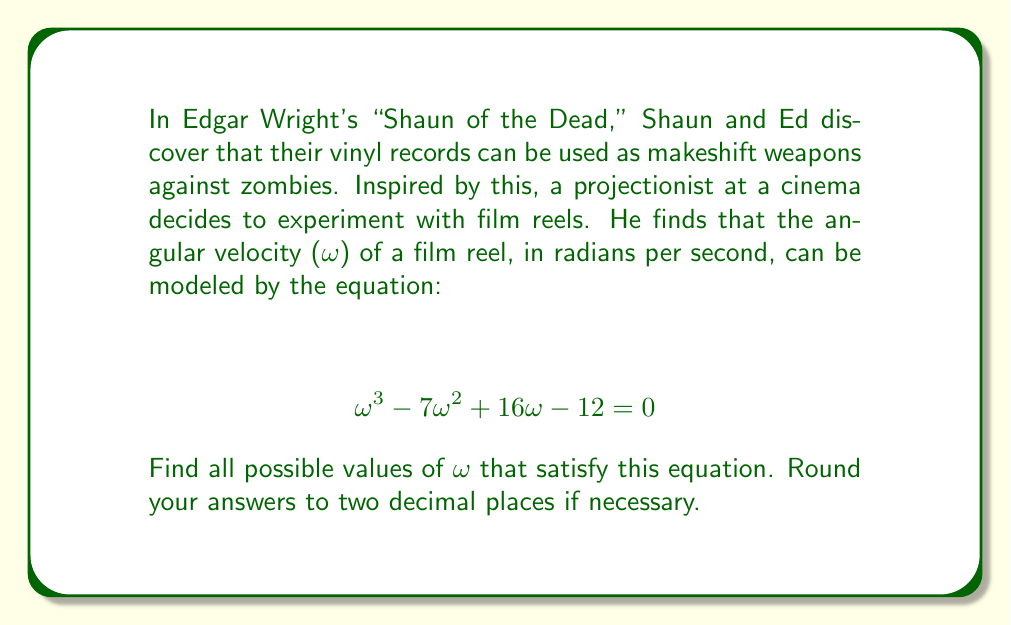Show me your answer to this math problem. To solve this polynomial equation, we'll use the following steps:

1) First, we recognize this as a cubic equation in the form $ax^3 + bx^2 + cx + d = 0$, where $a=1$, $b=-7$, $c=16$, and $d=-12$.

2) We can try to factor this equation. Let's check if there are any rational roots using the rational root theorem. The possible rational roots are the factors of the constant term (12): ±1, ±2, ±3, ±4, ±6, ±12.

3) Testing these values, we find that $\omega = 2$ is a solution:

   $2^3 - 7(2^2) + 16(2) - 12 = 8 - 28 + 32 - 12 = 0$

4) Now that we've found one root, we can factor out $(ω - 2)$:

   $(\omega - 2)(\omega^2 - 5\omega + 6) = 0$

5) The quadratic factor $\omega^2 - 5\omega + 6$ can be solved using the quadratic formula:

   $\omega = \frac{-b \pm \sqrt{b^2 - 4ac}}{2a}$

   Where $a=1$, $b=-5$, and $c=6$

6) Substituting these values:

   $\omega = \frac{5 \pm \sqrt{25 - 24}}{2} = \frac{5 \pm 1}{2}$

7) This gives us two more solutions:

   $\omega = \frac{5 + 1}{2} = 3$ and $\omega = \frac{5 - 1}{2} = 2$

Therefore, the three solutions are $\omega = 2$, $\omega = 3$, and $\omega = 2$.
Answer: The angular velocities that satisfy the equation are 2 rad/s and 3 rad/s. 